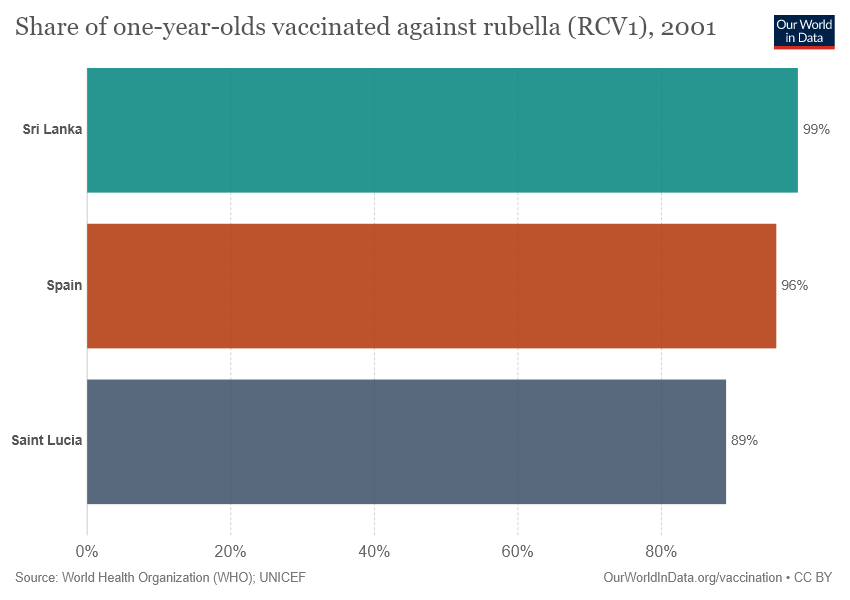Highlight a few significant elements in this photo. The value for Sri Lanka is 0.99. The median percentage in both Sri Lanka and Saint Lucia is greater than their respective average percentages. 